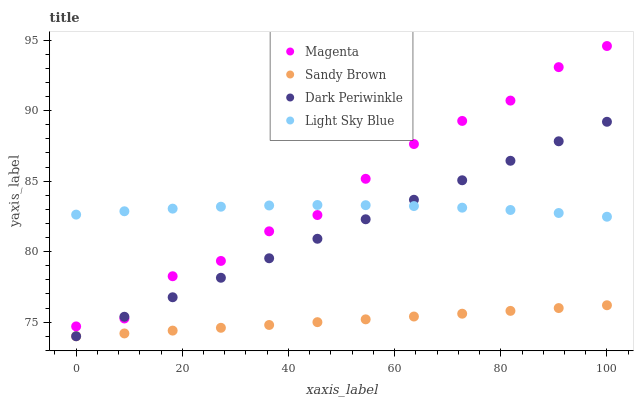Does Sandy Brown have the minimum area under the curve?
Answer yes or no. Yes. Does Magenta have the maximum area under the curve?
Answer yes or no. Yes. Does Light Sky Blue have the minimum area under the curve?
Answer yes or no. No. Does Light Sky Blue have the maximum area under the curve?
Answer yes or no. No. Is Dark Periwinkle the smoothest?
Answer yes or no. Yes. Is Magenta the roughest?
Answer yes or no. Yes. Is Light Sky Blue the smoothest?
Answer yes or no. No. Is Light Sky Blue the roughest?
Answer yes or no. No. Does Sandy Brown have the lowest value?
Answer yes or no. Yes. Does Light Sky Blue have the lowest value?
Answer yes or no. No. Does Magenta have the highest value?
Answer yes or no. Yes. Does Light Sky Blue have the highest value?
Answer yes or no. No. Is Sandy Brown less than Magenta?
Answer yes or no. Yes. Is Magenta greater than Sandy Brown?
Answer yes or no. Yes. Does Light Sky Blue intersect Dark Periwinkle?
Answer yes or no. Yes. Is Light Sky Blue less than Dark Periwinkle?
Answer yes or no. No. Is Light Sky Blue greater than Dark Periwinkle?
Answer yes or no. No. Does Sandy Brown intersect Magenta?
Answer yes or no. No. 